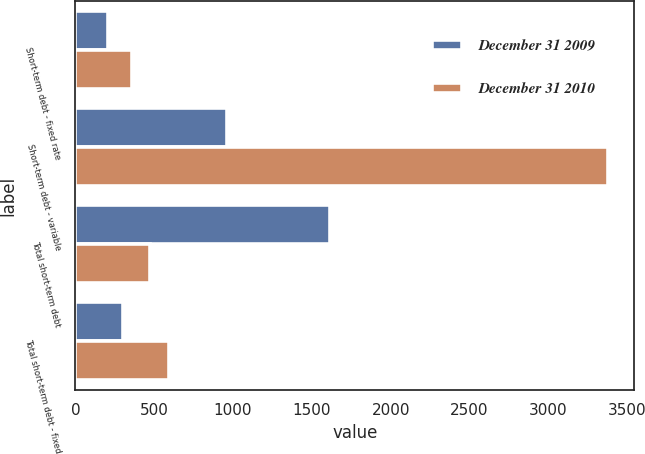<chart> <loc_0><loc_0><loc_500><loc_500><stacked_bar_chart><ecel><fcel>Short-term debt - fixed rate<fcel>Short-term debt - variable<fcel>Total short-term debt<fcel>Total short-term debt - fixed<nl><fcel>December 31 2009<fcel>209<fcel>964<fcel>1616<fcel>305<nl><fcel>December 31 2010<fcel>360<fcel>3376<fcel>476<fcel>592<nl></chart> 